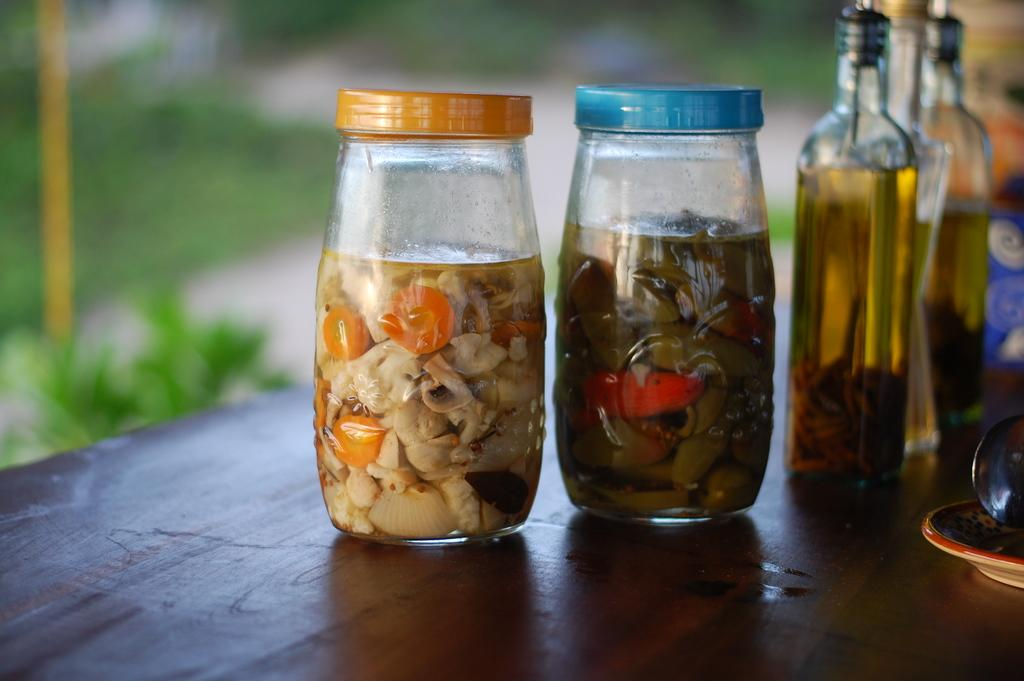What objects are on the table in the image? There are bottles on a table in the image. What is inside some of the bottles? Some bottles contain food storage, while others contain liquid. How is the background of the bottles depicted in the image? The background of the bottles is blurred. What type of silk fabric is draped over the bottles in the image? There is no silk fabric present in the image; it only features bottles on a table. 